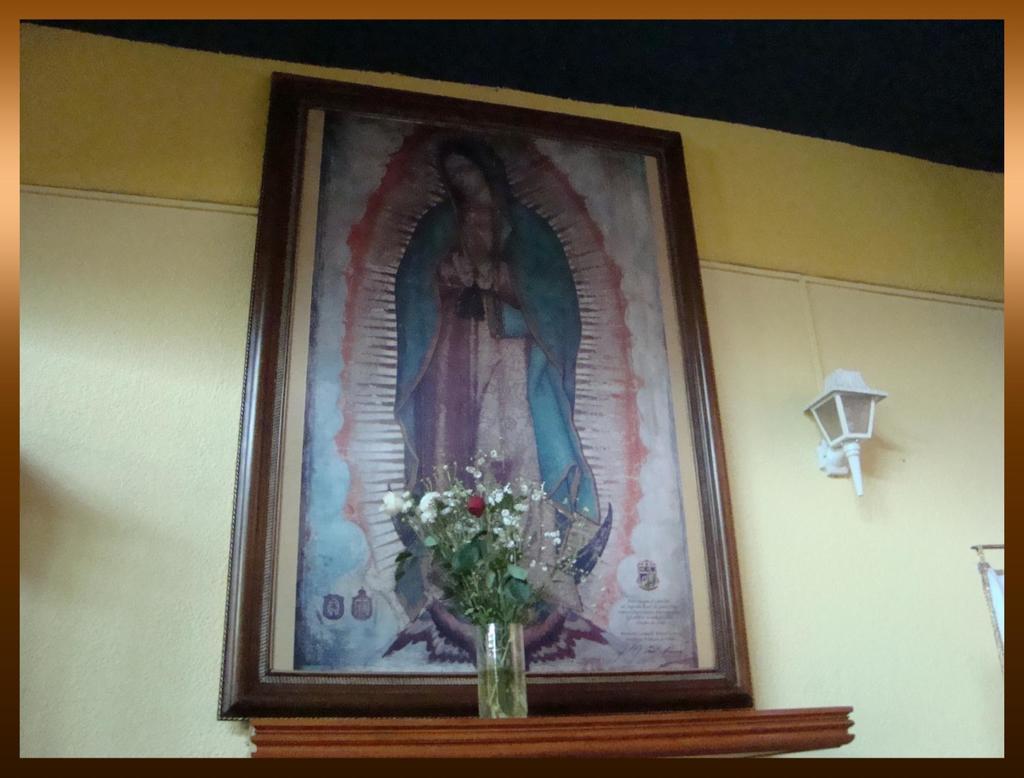In one or two sentences, can you explain what this image depicts? In this image there is a photo frame on the wall, beside the photo frame there is a lamp, in front of the photo frame there are flowers on the wooden platform. 